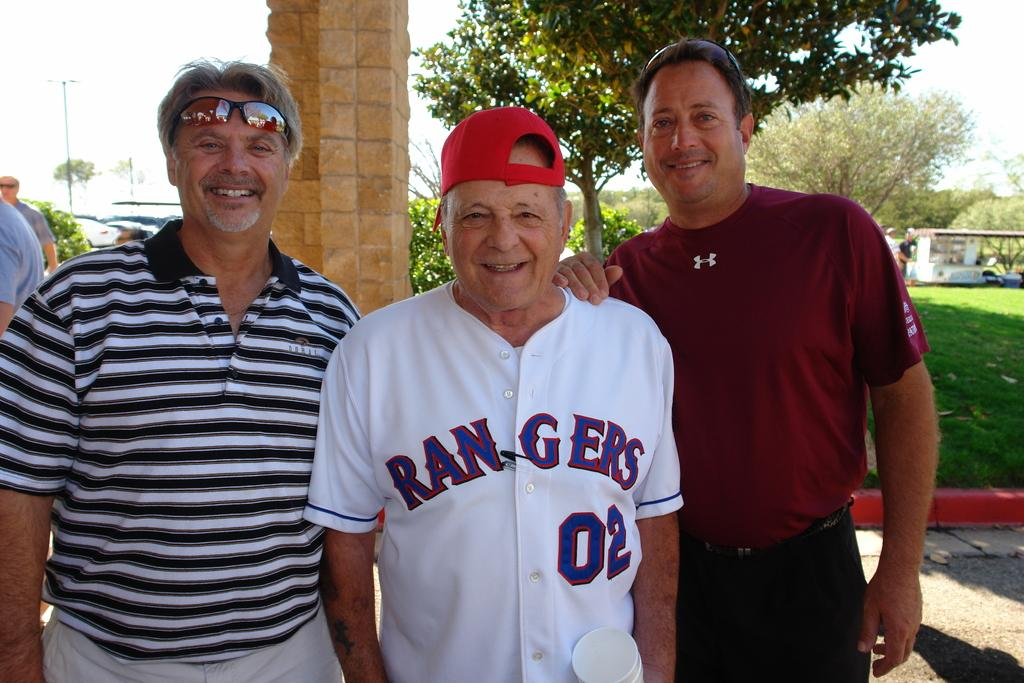<image>
Relay a brief, clear account of the picture shown. Two men pose for a picture with an older man that is wearing a Rangers jersey for player number two. 